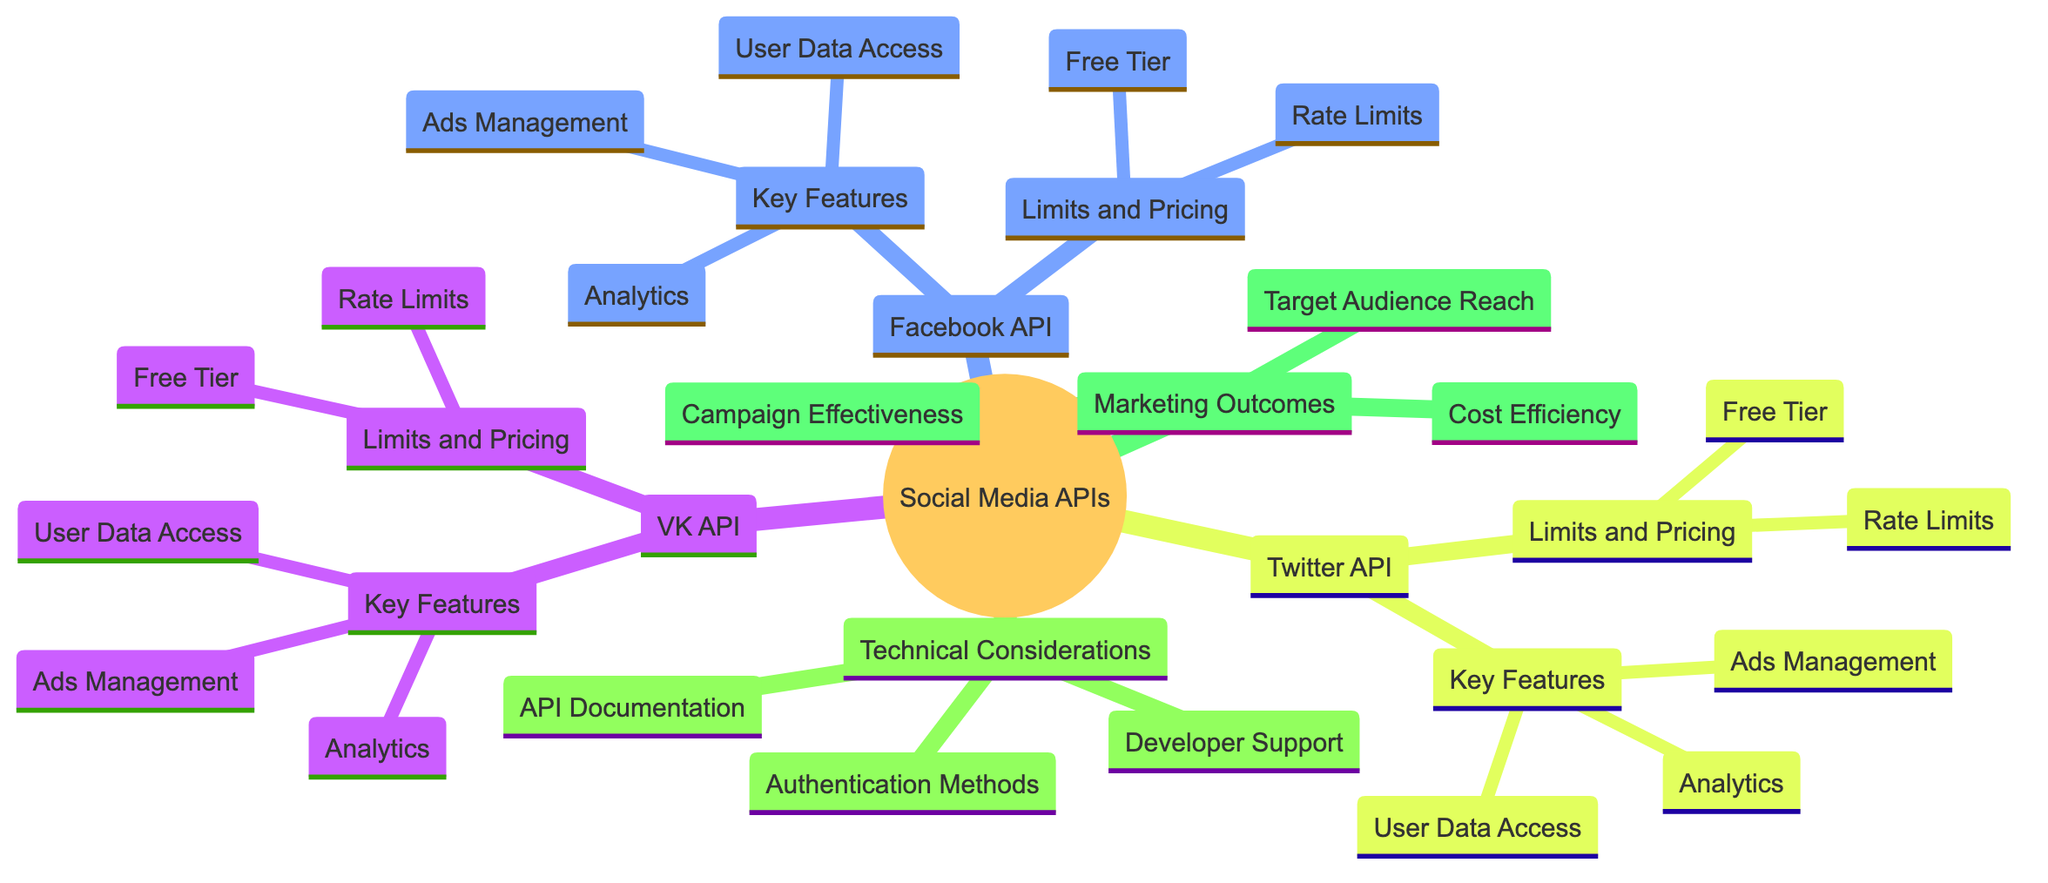What are the key features of VK API? The key features of VK API include Ads Management, User Data Access, and Analytics. This information can be found directly under the VK API node as its sub-nodes.
Answer: Ads Management, User Data Access, Analytics How many social media platforms are compared in the diagram? The diagram includes three social media platforms: VK API, Facebook API, and Twitter API. These platforms are listed as children under the Social Media Platforms node.
Answer: 3 What is one technical consideration mentioned in the diagram? One technical consideration mentioned is API Documentation, which is listed as a child under the Technical Considerations node.
Answer: API Documentation What are the limits and pricing options for Twitter API? The limits and pricing options for Twitter API include a Free Tier and Rate Limits. These are specified under the Limits and Pricing section for the Twitter API node.
Answer: Free Tier, Rate Limits Which social media API has user data access as a key feature? Both VK API and Facebook API have User Data Access as a key feature, indicated under their respective Key Features sections.
Answer: VK API, Facebook API How many marketing outcomes are identified in the diagram? The diagram identifies three marketing outcomes: Campaign Effectiveness, Target Audience Reach, and Cost Efficiency, all located under the Marketing Outcomes node.
Answer: 3 What is the relationship between 'Developer Support' and 'Technical Considerations'? 'Developer Support' is a child node under the 'Technical Considerations' node, indicating it is part of the broader category of technical aspects relevant to social media APIs.
Answer: Child node Which API has a Free Tier option? All three APIs—VK API, Facebook API, and Twitter API—have a Free Tier option available, as listed under their respective Limits and Pricing sections.
Answer: VK API, Facebook API, Twitter API What is one outcome related to marketing effectiveness mentioned in the diagram? One outcome related to marketing effectiveness is Campaign Effectiveness, which is explicitly noted as a child under the Marketing Outcomes node in the diagram.
Answer: Campaign Effectiveness 